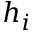Convert formula to latex. <formula><loc_0><loc_0><loc_500><loc_500>h _ { i }</formula> 